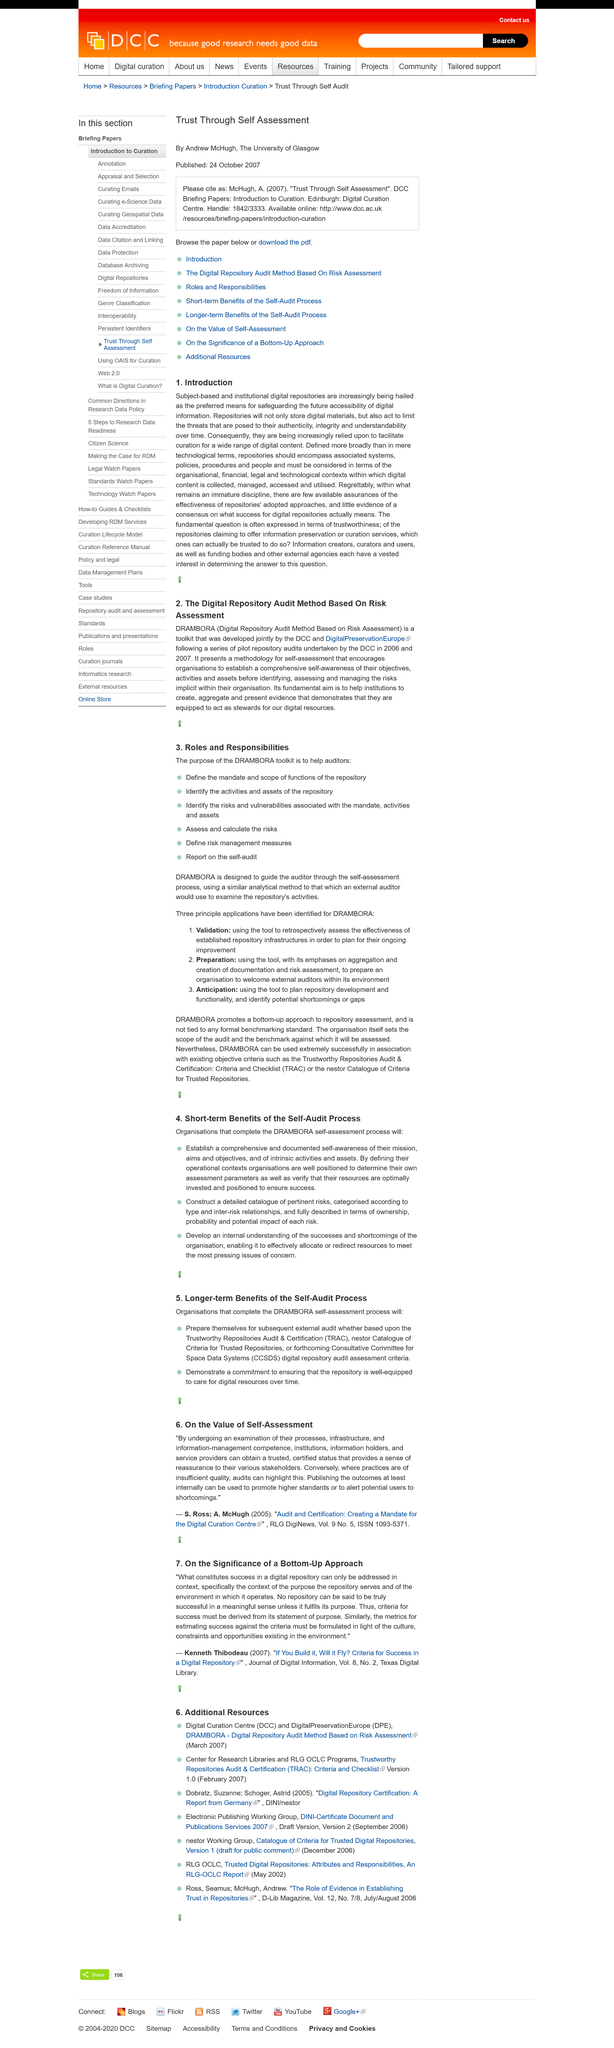Outline some significant characteristics in this image. The fundamental aim of DRAMBORA is to assist institutions in demonstrating their capabilities as digital stewards by creating, aggregating, and presenting compelling evidence of their qualifications. The development of DRAMBORA was a collaborative effort between the Digital Curation Centre (DCC) and DigitalPreservationEurope (DPE). DRAMBORA stands for Digital Repository Audit Method Based on Risk Assessment. 